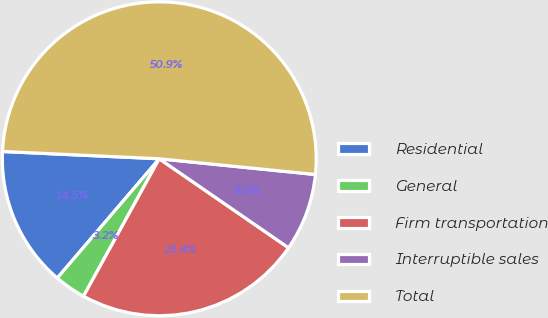Convert chart. <chart><loc_0><loc_0><loc_500><loc_500><pie_chart><fcel>Residential<fcel>General<fcel>Firm transportation<fcel>Interruptible sales<fcel>Total<nl><fcel>14.48%<fcel>3.24%<fcel>23.42%<fcel>8.0%<fcel>50.86%<nl></chart> 